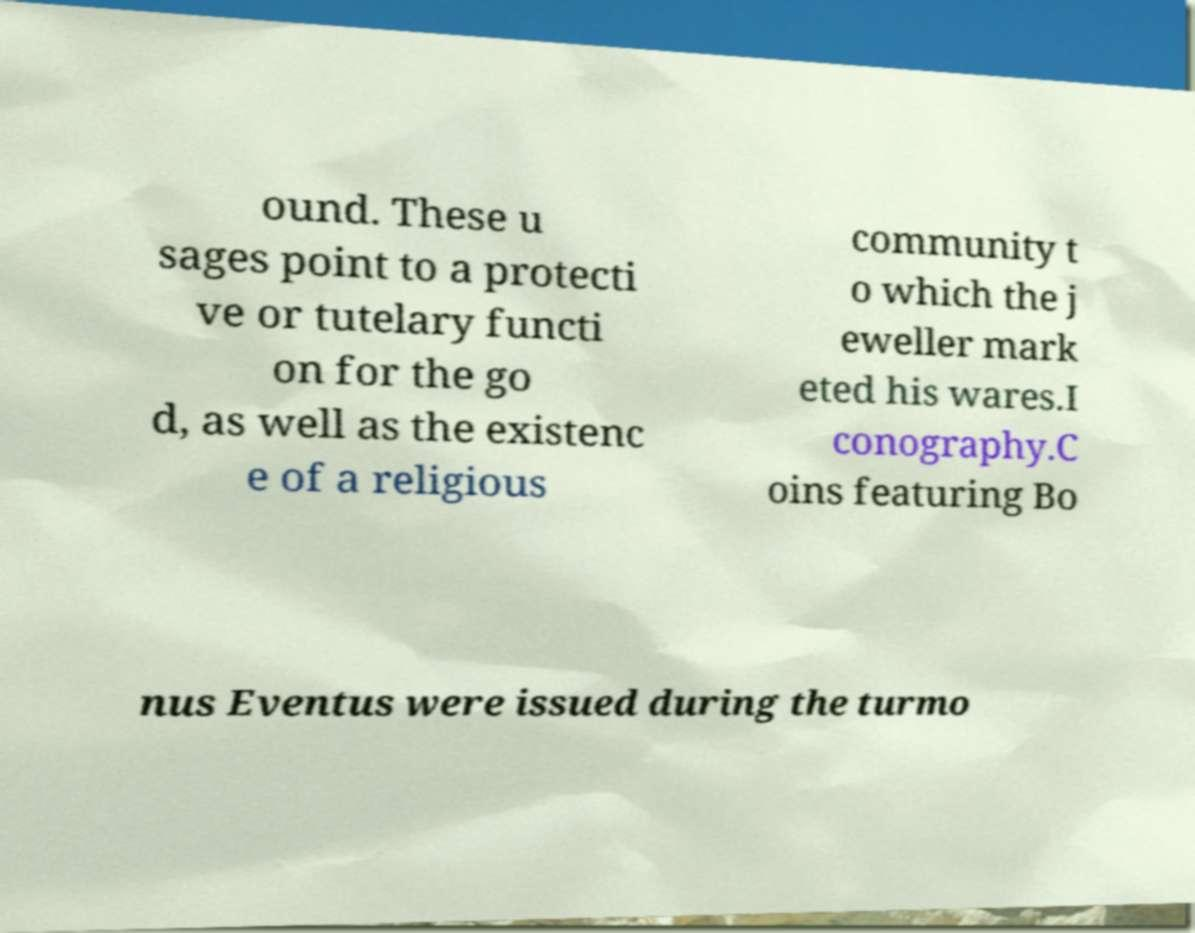There's text embedded in this image that I need extracted. Can you transcribe it verbatim? ound. These u sages point to a protecti ve or tutelary functi on for the go d, as well as the existenc e of a religious community t o which the j eweller mark eted his wares.I conography.C oins featuring Bo nus Eventus were issued during the turmo 